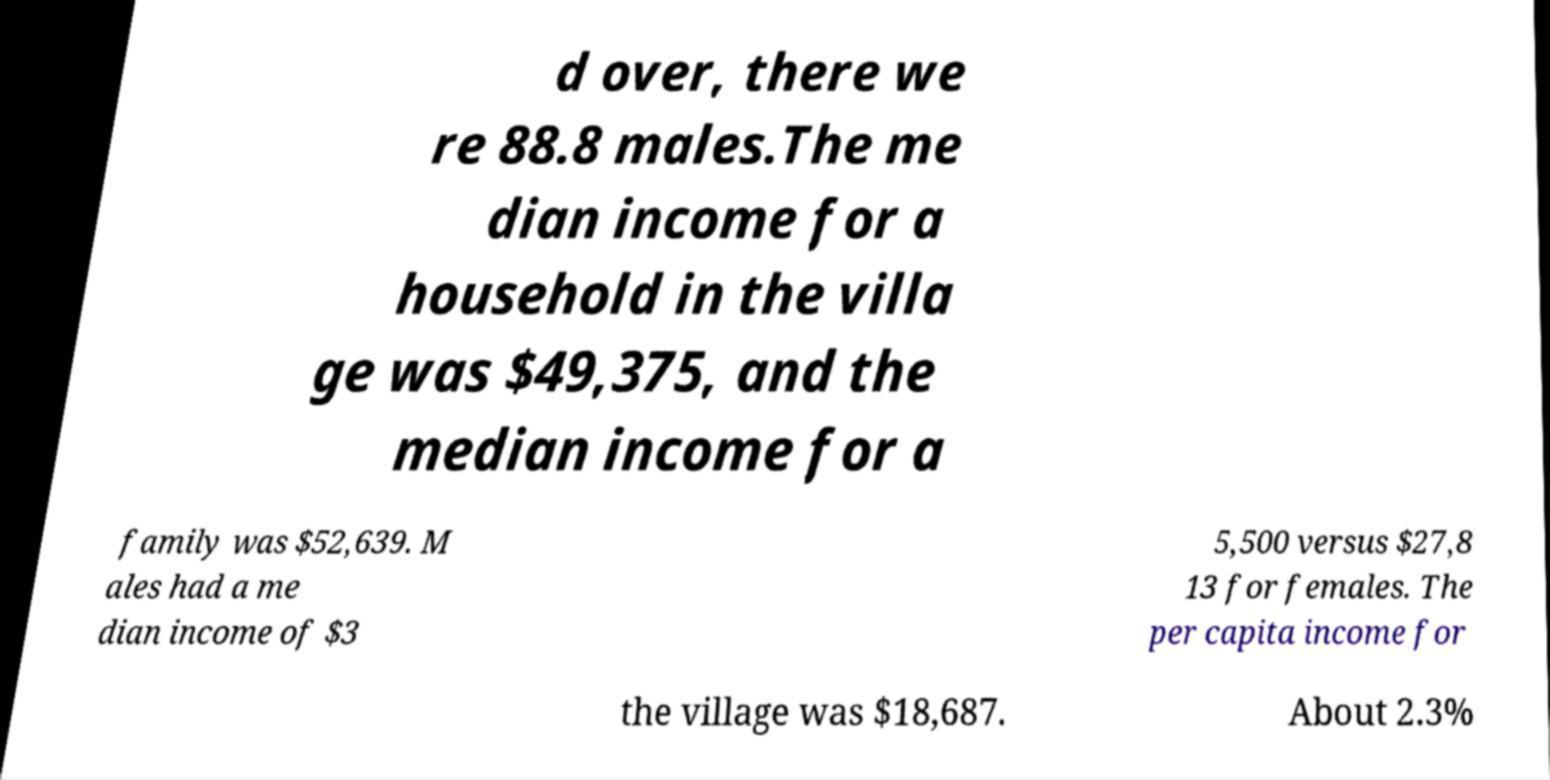Can you read and provide the text displayed in the image?This photo seems to have some interesting text. Can you extract and type it out for me? d over, there we re 88.8 males.The me dian income for a household in the villa ge was $49,375, and the median income for a family was $52,639. M ales had a me dian income of $3 5,500 versus $27,8 13 for females. The per capita income for the village was $18,687. About 2.3% 